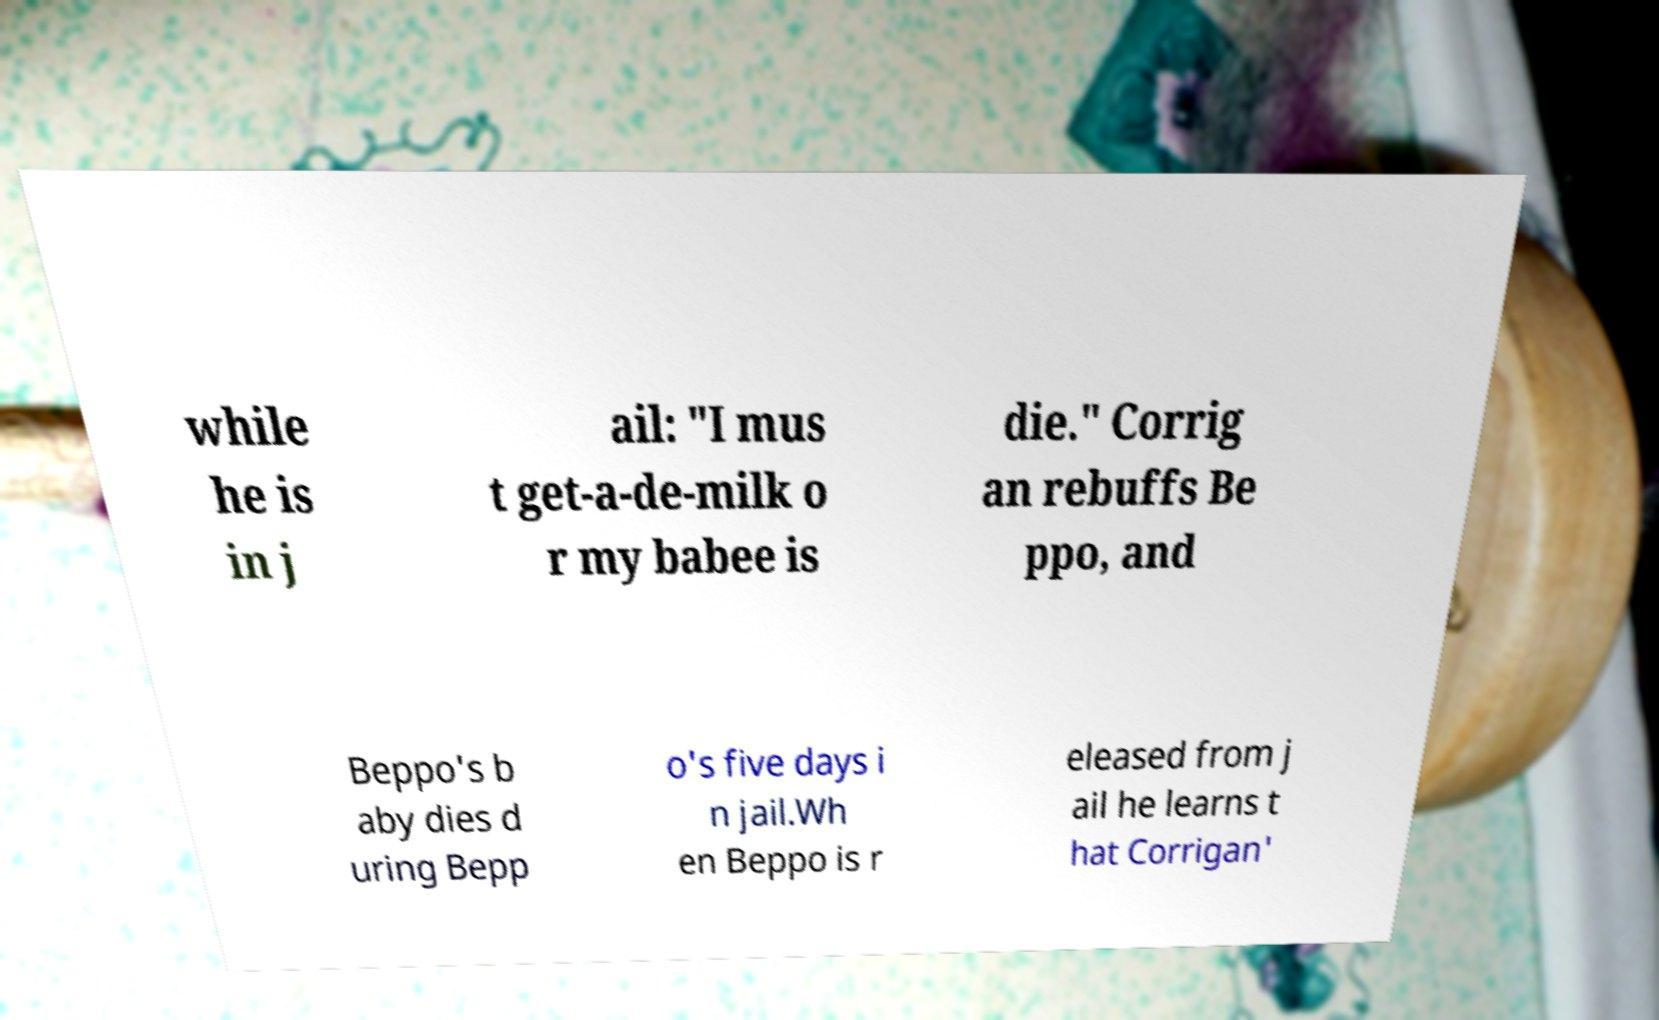I need the written content from this picture converted into text. Can you do that? while he is in j ail: "I mus t get-a-de-milk o r my babee is die." Corrig an rebuffs Be ppo, and Beppo's b aby dies d uring Bepp o's five days i n jail.Wh en Beppo is r eleased from j ail he learns t hat Corrigan' 